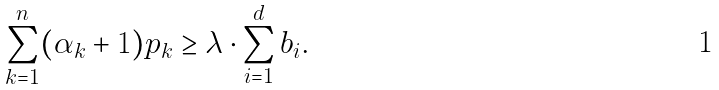Convert formula to latex. <formula><loc_0><loc_0><loc_500><loc_500>\sum _ { k = 1 } ^ { n } ( \alpha _ { k } + 1 ) p _ { k } \geq \lambda \cdot \sum _ { i = 1 } ^ { d } b _ { i } .</formula> 